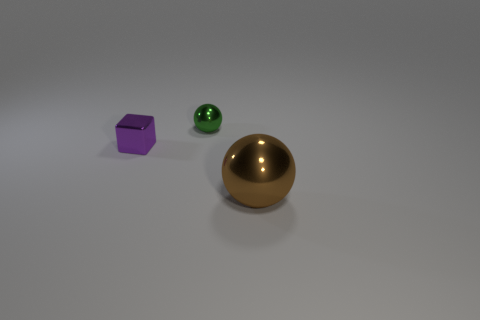Subtract all blue cubes. Subtract all brown spheres. How many cubes are left? 1 Add 3 tiny yellow metal blocks. How many objects exist? 6 Subtract all spheres. How many objects are left? 1 Subtract all large cyan rubber cubes. Subtract all tiny things. How many objects are left? 1 Add 3 big brown spheres. How many big brown spheres are left? 4 Add 3 tiny metal blocks. How many tiny metal blocks exist? 4 Subtract 0 yellow cylinders. How many objects are left? 3 